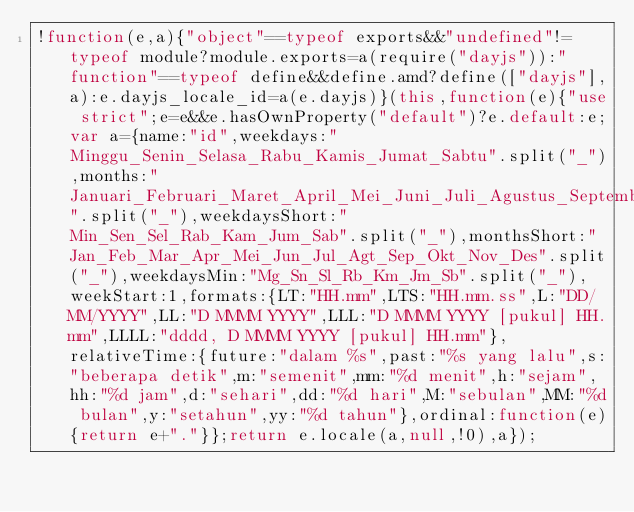Convert code to text. <code><loc_0><loc_0><loc_500><loc_500><_JavaScript_>!function(e,a){"object"==typeof exports&&"undefined"!=typeof module?module.exports=a(require("dayjs")):"function"==typeof define&&define.amd?define(["dayjs"],a):e.dayjs_locale_id=a(e.dayjs)}(this,function(e){"use strict";e=e&&e.hasOwnProperty("default")?e.default:e;var a={name:"id",weekdays:"Minggu_Senin_Selasa_Rabu_Kamis_Jumat_Sabtu".split("_"),months:"Januari_Februari_Maret_April_Mei_Juni_Juli_Agustus_September_Oktober_November_Desember".split("_"),weekdaysShort:"Min_Sen_Sel_Rab_Kam_Jum_Sab".split("_"),monthsShort:"Jan_Feb_Mar_Apr_Mei_Jun_Jul_Agt_Sep_Okt_Nov_Des".split("_"),weekdaysMin:"Mg_Sn_Sl_Rb_Km_Jm_Sb".split("_"),weekStart:1,formats:{LT:"HH.mm",LTS:"HH.mm.ss",L:"DD/MM/YYYY",LL:"D MMMM YYYY",LLL:"D MMMM YYYY [pukul] HH.mm",LLLL:"dddd, D MMMM YYYY [pukul] HH.mm"},relativeTime:{future:"dalam %s",past:"%s yang lalu",s:"beberapa detik",m:"semenit",mm:"%d menit",h:"sejam",hh:"%d jam",d:"sehari",dd:"%d hari",M:"sebulan",MM:"%d bulan",y:"setahun",yy:"%d tahun"},ordinal:function(e){return e+"."}};return e.locale(a,null,!0),a});
</code> 